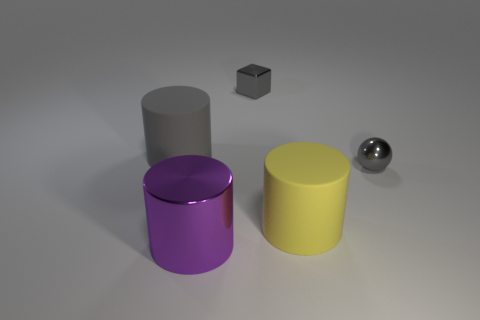Is there anything else that has the same material as the purple object?
Offer a terse response. Yes. What number of tiny gray objects have the same shape as the yellow rubber object?
Provide a short and direct response. 0. What is the material of the large cylinder that is the same color as the tiny metal block?
Your answer should be very brief. Rubber. Are there any other things that have the same shape as the purple thing?
Ensure brevity in your answer.  Yes. What color is the rubber thing in front of the tiny gray shiny object that is to the right of the tiny object that is to the left of the yellow rubber cylinder?
Keep it short and to the point. Yellow. What number of small things are red rubber spheres or cubes?
Give a very brief answer. 1. Are there an equal number of yellow cylinders that are on the left side of the small gray cube and small purple blocks?
Provide a succinct answer. Yes. Are there any gray spheres behind the big purple cylinder?
Your answer should be compact. Yes. What number of metallic objects are either gray objects or large yellow objects?
Your response must be concise. 2. What number of big purple shiny things are behind the big gray cylinder?
Keep it short and to the point. 0. 